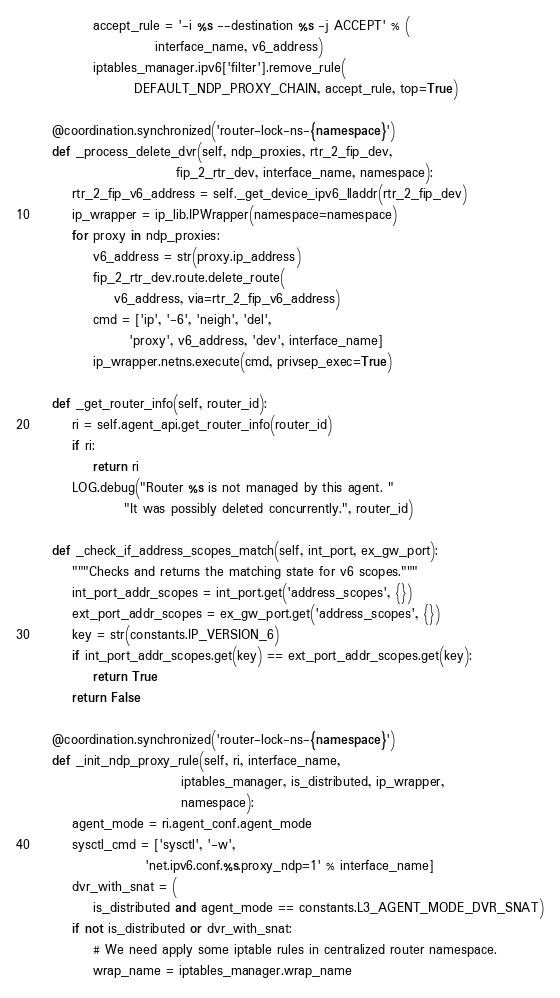Convert code to text. <code><loc_0><loc_0><loc_500><loc_500><_Python_>            accept_rule = '-i %s --destination %s -j ACCEPT' % (
                        interface_name, v6_address)
            iptables_manager.ipv6['filter'].remove_rule(
                    DEFAULT_NDP_PROXY_CHAIN, accept_rule, top=True)

    @coordination.synchronized('router-lock-ns-{namespace}')
    def _process_delete_dvr(self, ndp_proxies, rtr_2_fip_dev,
                            fip_2_rtr_dev, interface_name, namespace):
        rtr_2_fip_v6_address = self._get_device_ipv6_lladdr(rtr_2_fip_dev)
        ip_wrapper = ip_lib.IPWrapper(namespace=namespace)
        for proxy in ndp_proxies:
            v6_address = str(proxy.ip_address)
            fip_2_rtr_dev.route.delete_route(
                v6_address, via=rtr_2_fip_v6_address)
            cmd = ['ip', '-6', 'neigh', 'del',
                   'proxy', v6_address, 'dev', interface_name]
            ip_wrapper.netns.execute(cmd, privsep_exec=True)

    def _get_router_info(self, router_id):
        ri = self.agent_api.get_router_info(router_id)
        if ri:
            return ri
        LOG.debug("Router %s is not managed by this agent. "
                  "It was possibly deleted concurrently.", router_id)

    def _check_if_address_scopes_match(self, int_port, ex_gw_port):
        """Checks and returns the matching state for v6 scopes."""
        int_port_addr_scopes = int_port.get('address_scopes', {})
        ext_port_addr_scopes = ex_gw_port.get('address_scopes', {})
        key = str(constants.IP_VERSION_6)
        if int_port_addr_scopes.get(key) == ext_port_addr_scopes.get(key):
            return True
        return False

    @coordination.synchronized('router-lock-ns-{namespace}')
    def _init_ndp_proxy_rule(self, ri, interface_name,
                             iptables_manager, is_distributed, ip_wrapper,
                             namespace):
        agent_mode = ri.agent_conf.agent_mode
        sysctl_cmd = ['sysctl', '-w',
                      'net.ipv6.conf.%s.proxy_ndp=1' % interface_name]
        dvr_with_snat = (
            is_distributed and agent_mode == constants.L3_AGENT_MODE_DVR_SNAT)
        if not is_distributed or dvr_with_snat:
            # We need apply some iptable rules in centralized router namespace.
            wrap_name = iptables_manager.wrap_name</code> 